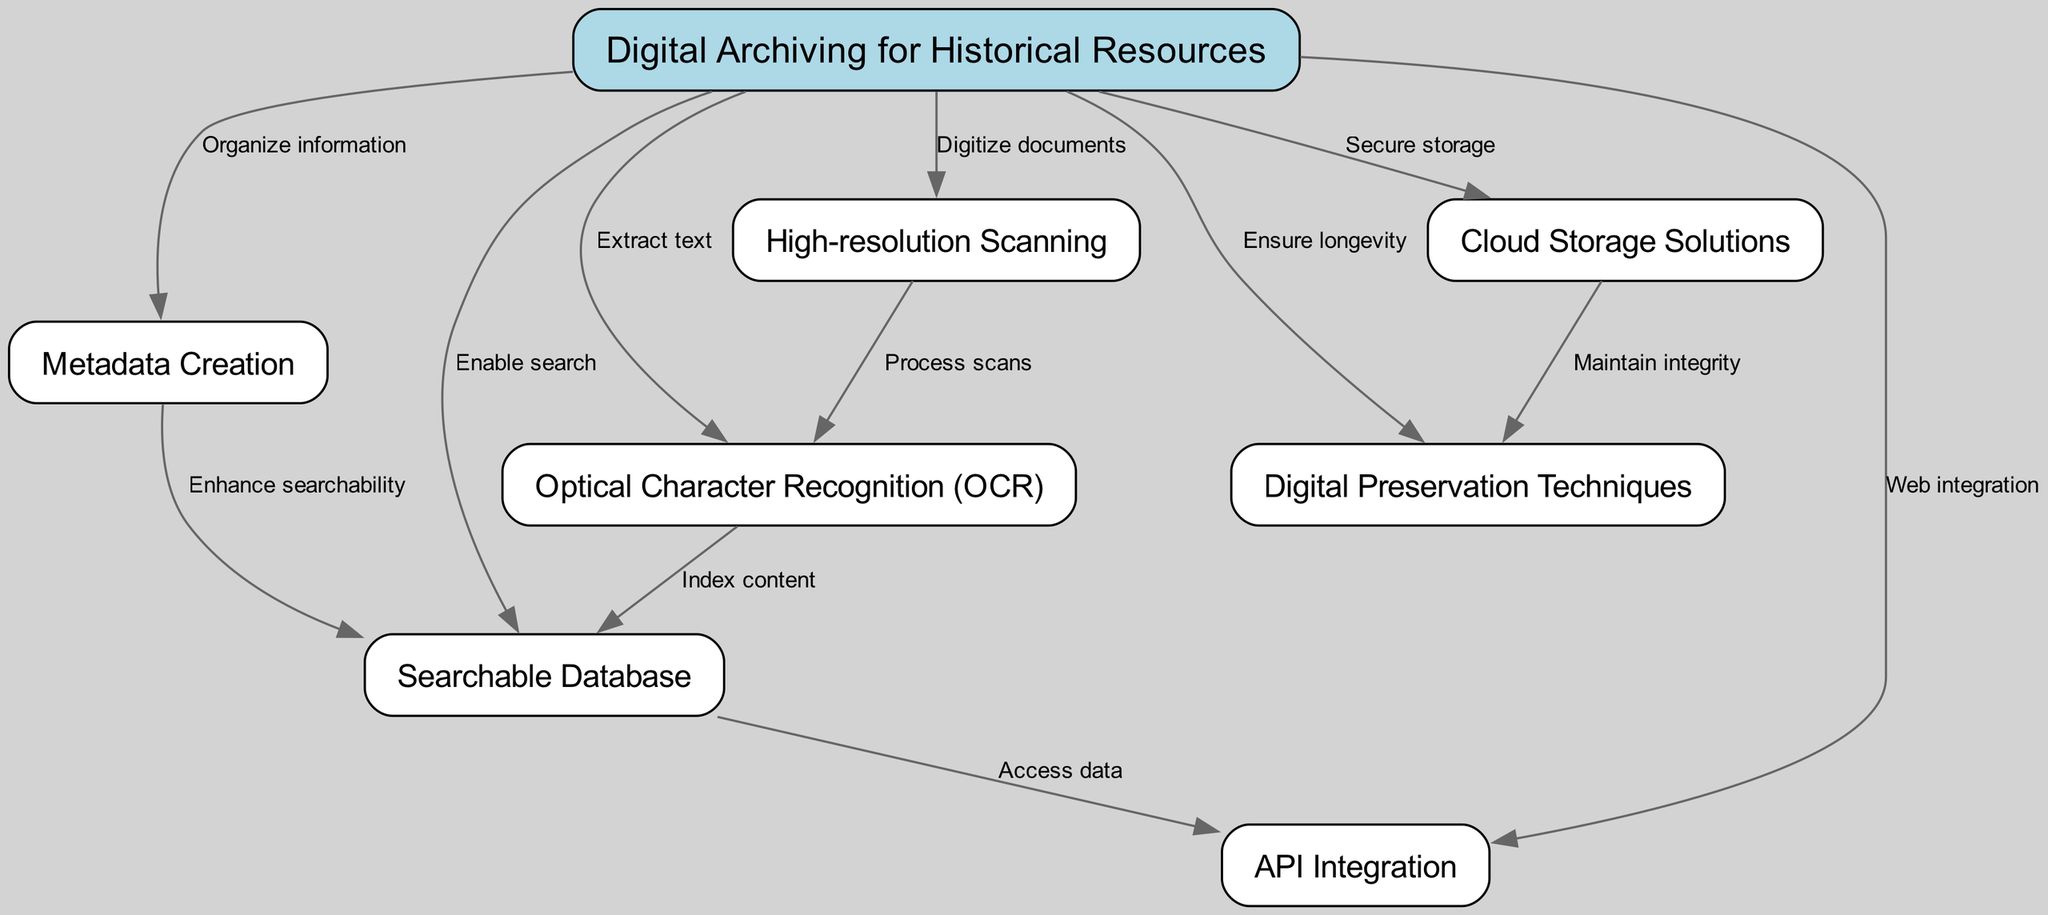What is the main focus of the diagram? The diagram centers around "Digital Archiving for Historical Resources," indicated by the root node at the top.
Answer: Digital Archiving for Historical Resources How many nodes are present in the diagram? By counting the nodes listed, there are a total of seven nodes including the root and six methods or techniques related to digital archiving.
Answer: 7 Which node is responsible for "Extract text"? The edge connecting the root node to the "Optical Character Recognition (OCR)" node indicates that OCR is the method responsible for text extraction.
Answer: Optical Character Recognition (OCR) What does the "High-resolution Scanning" lead to directly? The "High-resolution Scanning" node points to the "Optical Character Recognition (OCR)" node, indicating that scanning leads directly to text extraction.
Answer: Optical Character Recognition (OCR) What relationship exists between "Metadata Creation" and "Searchable Database"? The diagram shows that the "Metadata Creation" node enhances the searchability of the "Searchable Database," indicating an improvement in accessing historical documents.
Answer: Enhance searchability Which method ensures the longevity of digital records? The "Digital Preservation Techniques" node is designated in the diagram as the method that ensures the longevity of digital records.
Answer: Digital Preservation Techniques What type of storage is mentioned for securing digital data? The edge from the root node to the "Cloud Storage Solutions" node indicates that cloud storage is proposed for secure storage of digital data.
Answer: Cloud Storage Solutions How does the "Optical Character Recognition (OCR)" relate to the "Searchable Database"? OCR processes and indexes the content from scanned documents, which is then stored in the "Searchable Database" for easier access.
Answer: Index content What is a critical function of API Integration listed in the diagram? According to the diagram, the connection from the "Searchable Database" to the "API Integration" node suggests that API allows access to digital data.
Answer: Access data 